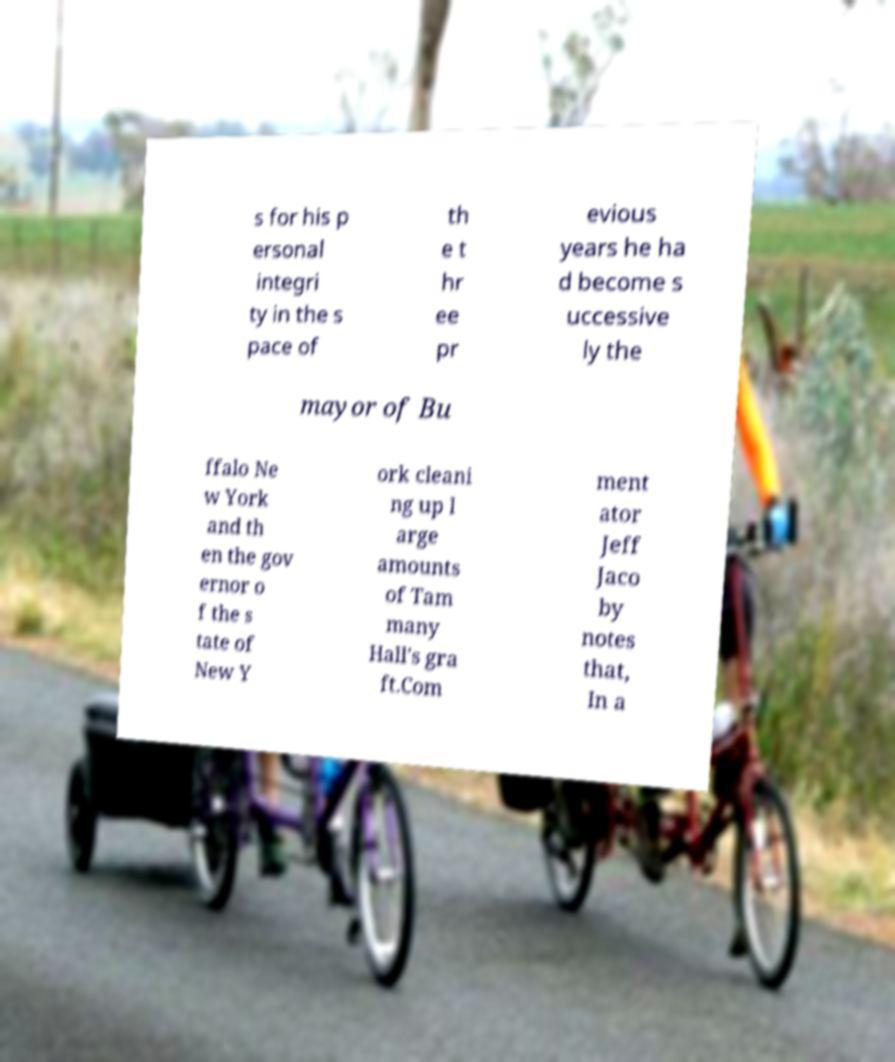Could you extract and type out the text from this image? s for his p ersonal integri ty in the s pace of th e t hr ee pr evious years he ha d become s uccessive ly the mayor of Bu ffalo Ne w York and th en the gov ernor o f the s tate of New Y ork cleani ng up l arge amounts of Tam many Hall's gra ft.Com ment ator Jeff Jaco by notes that, In a 